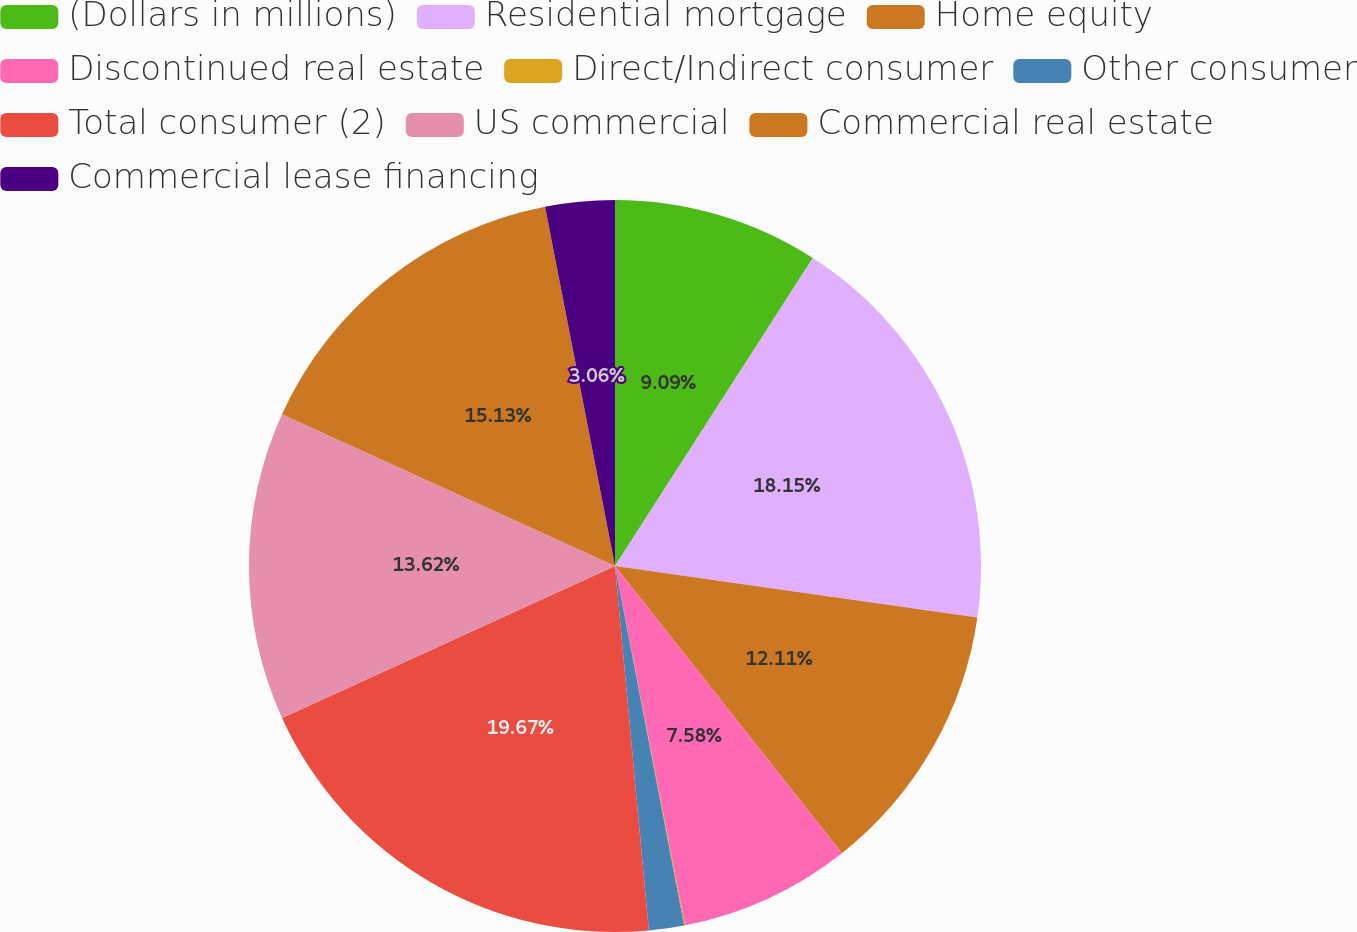Convert chart. <chart><loc_0><loc_0><loc_500><loc_500><pie_chart><fcel>(Dollars in millions)<fcel>Residential mortgage<fcel>Home equity<fcel>Discontinued real estate<fcel>Direct/Indirect consumer<fcel>Other consumer<fcel>Total consumer (2)<fcel>US commercial<fcel>Commercial real estate<fcel>Commercial lease financing<nl><fcel>9.09%<fcel>18.15%<fcel>12.11%<fcel>7.58%<fcel>0.04%<fcel>1.55%<fcel>19.66%<fcel>13.62%<fcel>15.13%<fcel>3.06%<nl></chart> 